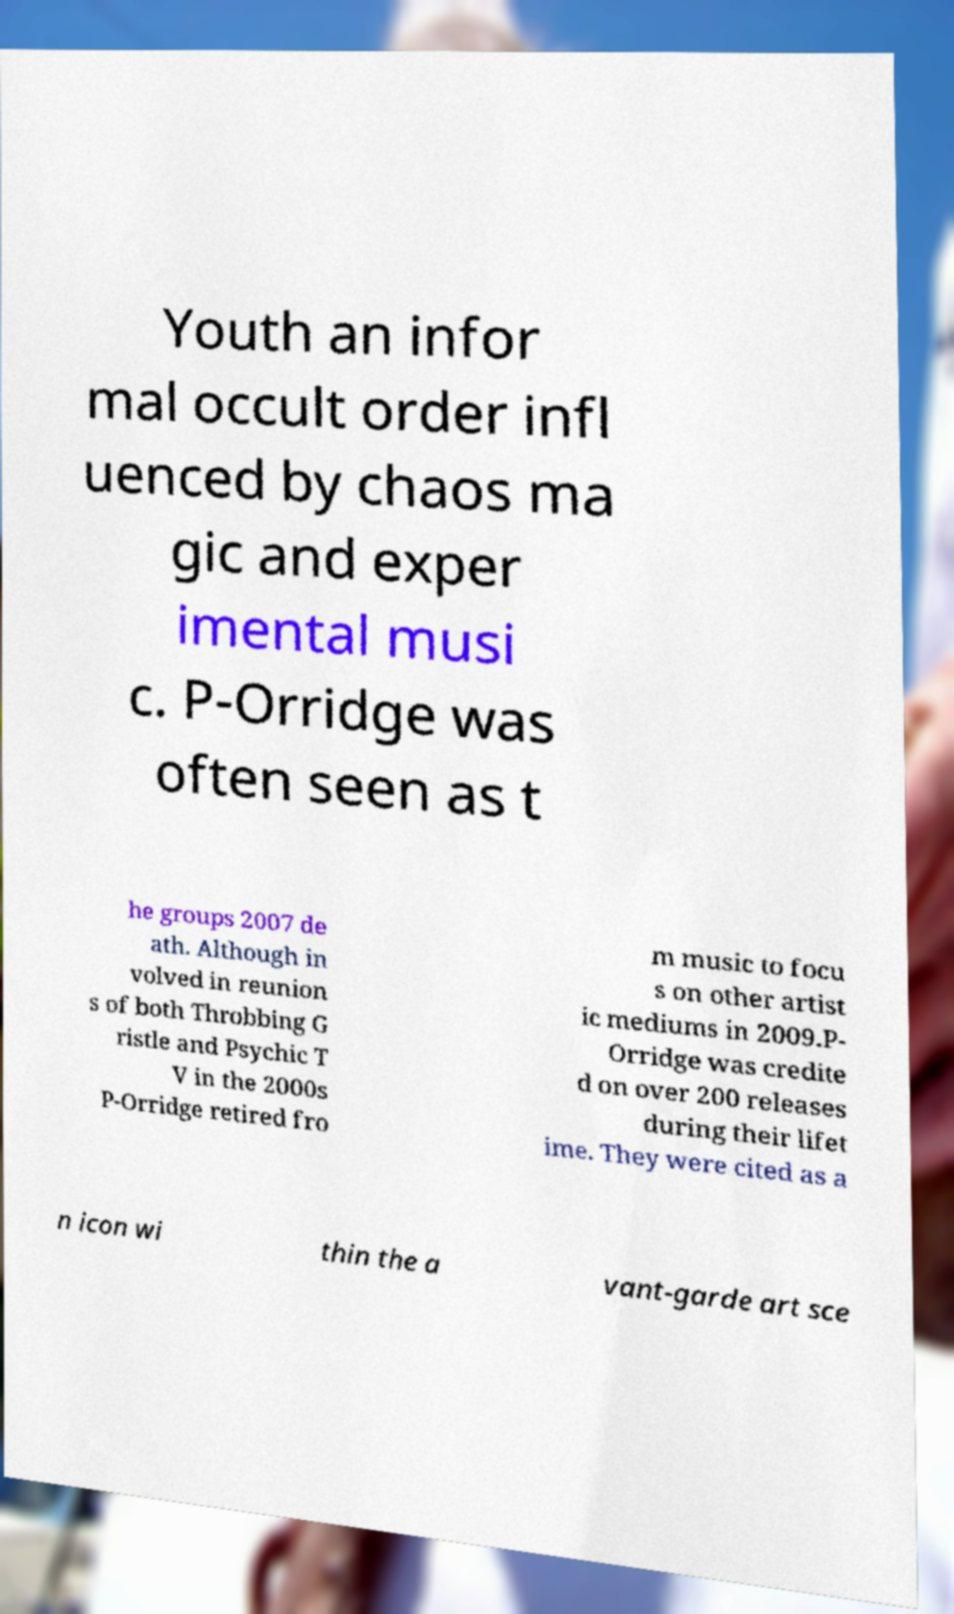Can you read and provide the text displayed in the image?This photo seems to have some interesting text. Can you extract and type it out for me? Youth an infor mal occult order infl uenced by chaos ma gic and exper imental musi c. P-Orridge was often seen as t he groups 2007 de ath. Although in volved in reunion s of both Throbbing G ristle and Psychic T V in the 2000s P-Orridge retired fro m music to focu s on other artist ic mediums in 2009.P- Orridge was credite d on over 200 releases during their lifet ime. They were cited as a n icon wi thin the a vant-garde art sce 